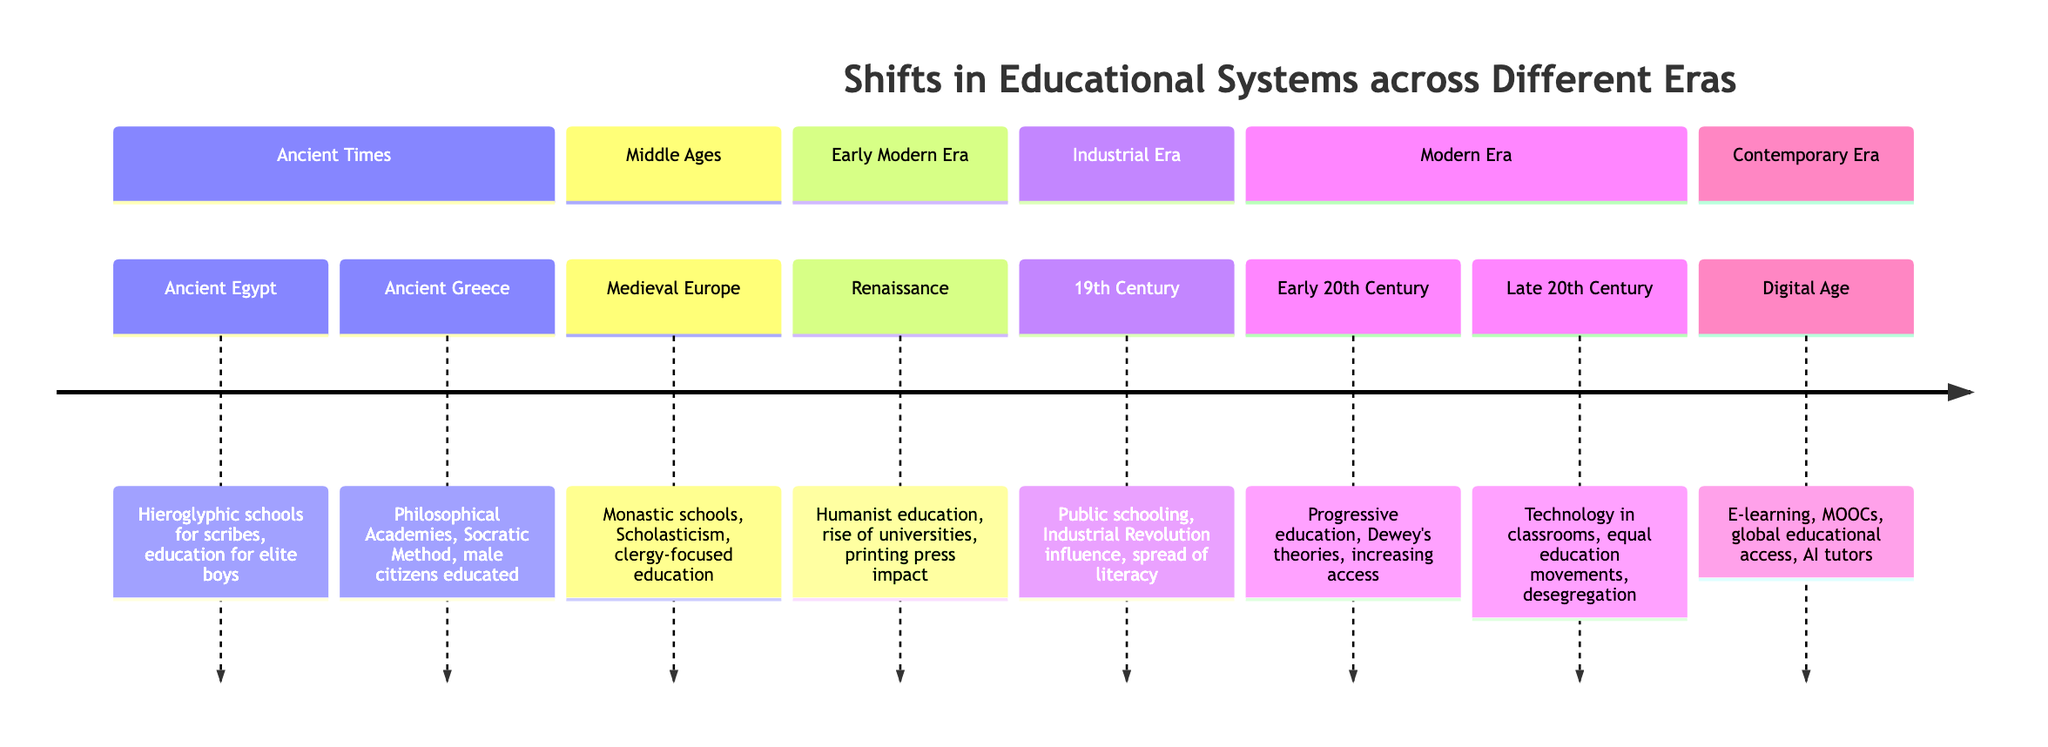What type of education existed in Ancient Greece? In the diagram, Ancient Greece is associated with "Philosophical Academies" and "Socratic Method", indicating the focus on philosophical education and critical thinking methods. This encapsulates the essence of education in that era.
Answer: Philosophical Academies What was a major influence on education during the Renaissance? The diagram mentions "Humanist education" and the "rise of universities" as key aspects of educational transformation during the Renaissance, highlighting a shift toward more secular and broad-based education.
Answer: Humanist education How many sections are there in the timeline? The timeline is divided into six distinct sections: Ancient Times, Middle Ages, Early Modern Era, Industrial Era, Modern Era, and Contemporary Era. By counting these sections, we can confirm the total.
Answer: 6 What was a key development in the Early 20th Century's education system? In the Early 20th Century section of the diagram, "Progressive education" and "Dewey's theories" are listed as significant developments, emphasizing a shift toward more progressive educational approaches.
Answer: Progressive education In which era did public schooling begin to emerge? The diagram specifies "Public schooling" as a significant feature of the 19th Century during the Industrial Era, indicating the introduction of structured public education systems at that time.
Answer: Industrial Era Which educational approach is associated with the Digital Age? The diagram describes "E-learning" and "MOOCs" as part of the Digital Age, indicating a move towards digital platforms for education and widespread access to learning resources.
Answer: E-learning What was the main focus of education during Medieval Europe? The diagram states that Medieval Europe had "Monastic schools, Scholasticism, clergy-focused education", indicating a primary focus on educating clergy and religious scholars during this period.
Answer: Clergy-focused education What technological advancement influenced education in the Renaissance? The diagram notes the impact of the "printing press" during the Renaissance, showcasing how this invention facilitated the spread of information and educational texts, transforming educational access.
Answer: Printing press What does the Late 20th Century emphasize in education? In the Late 20th Century section, the diagram mentions "Technology in classrooms" and "equal education movements", indicating an emphasis on integrating technology and promoting equal access to education during that time.
Answer: Equal education movements 